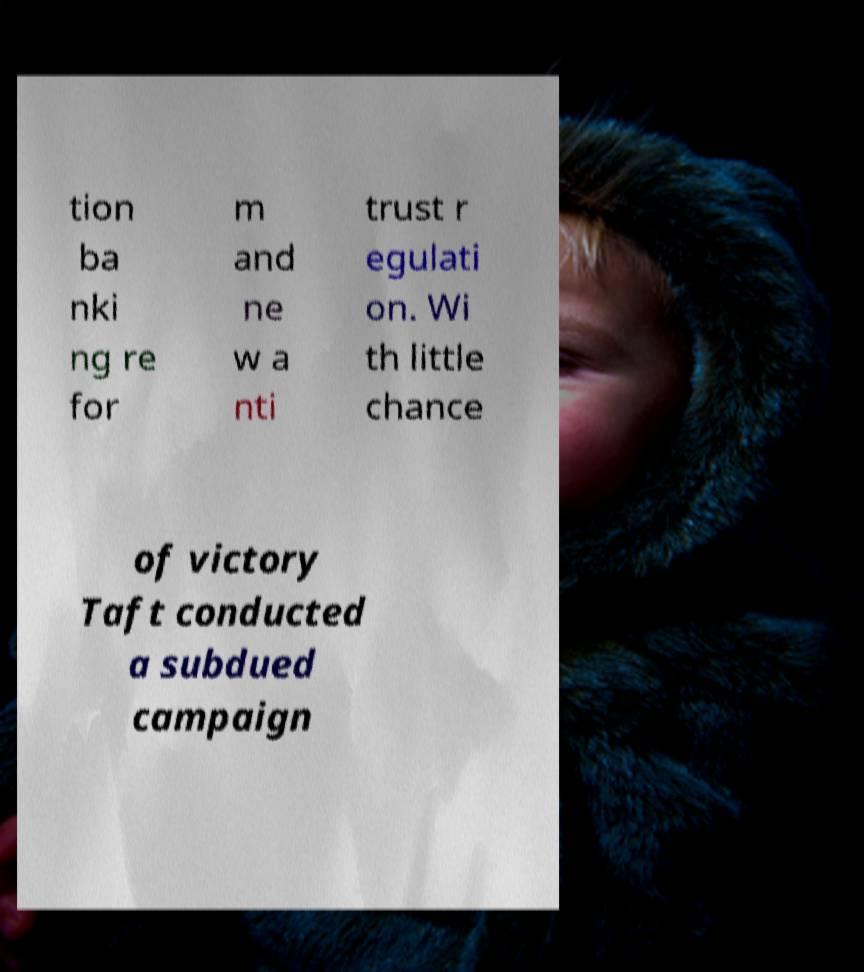Can you read and provide the text displayed in the image?This photo seems to have some interesting text. Can you extract and type it out for me? tion ba nki ng re for m and ne w a nti trust r egulati on. Wi th little chance of victory Taft conducted a subdued campaign 